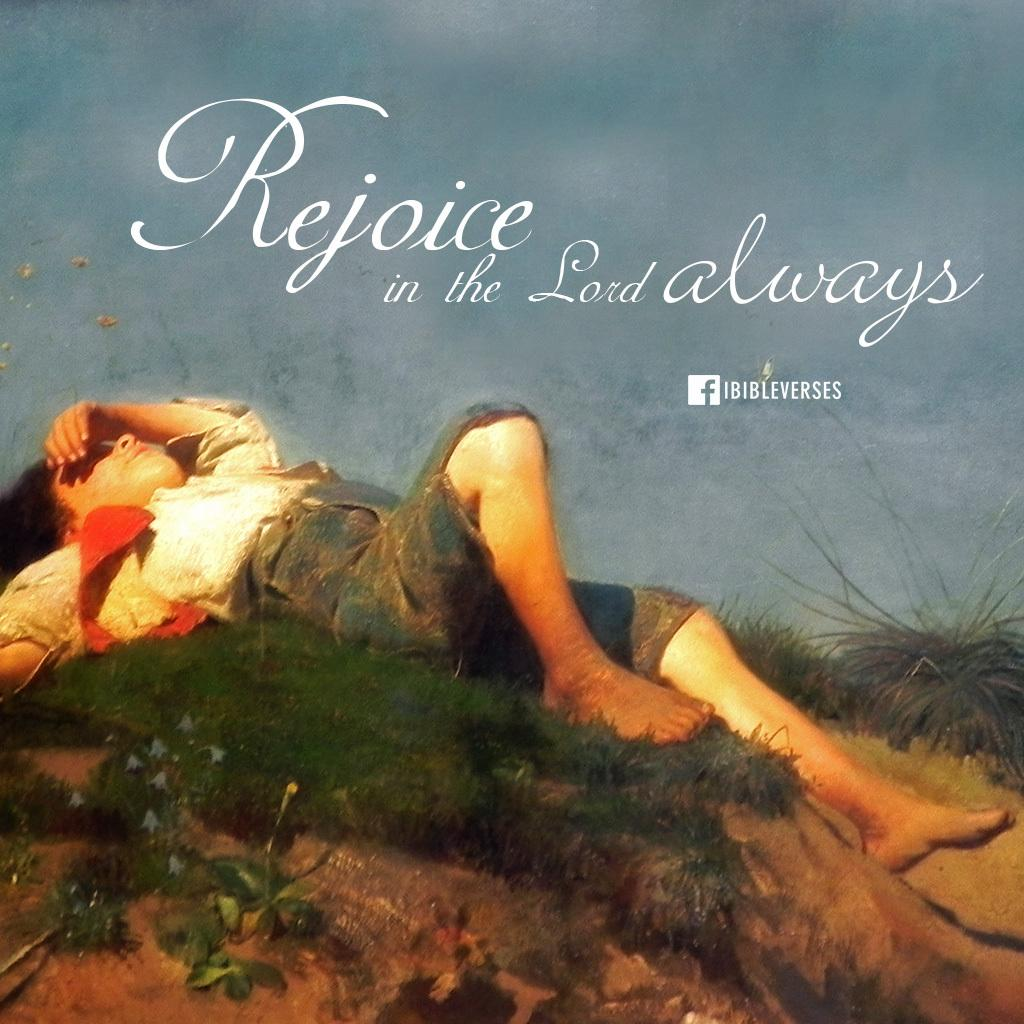<image>
Write a terse but informative summary of the picture. A album cover has a Facebook logo and a person laying down. 